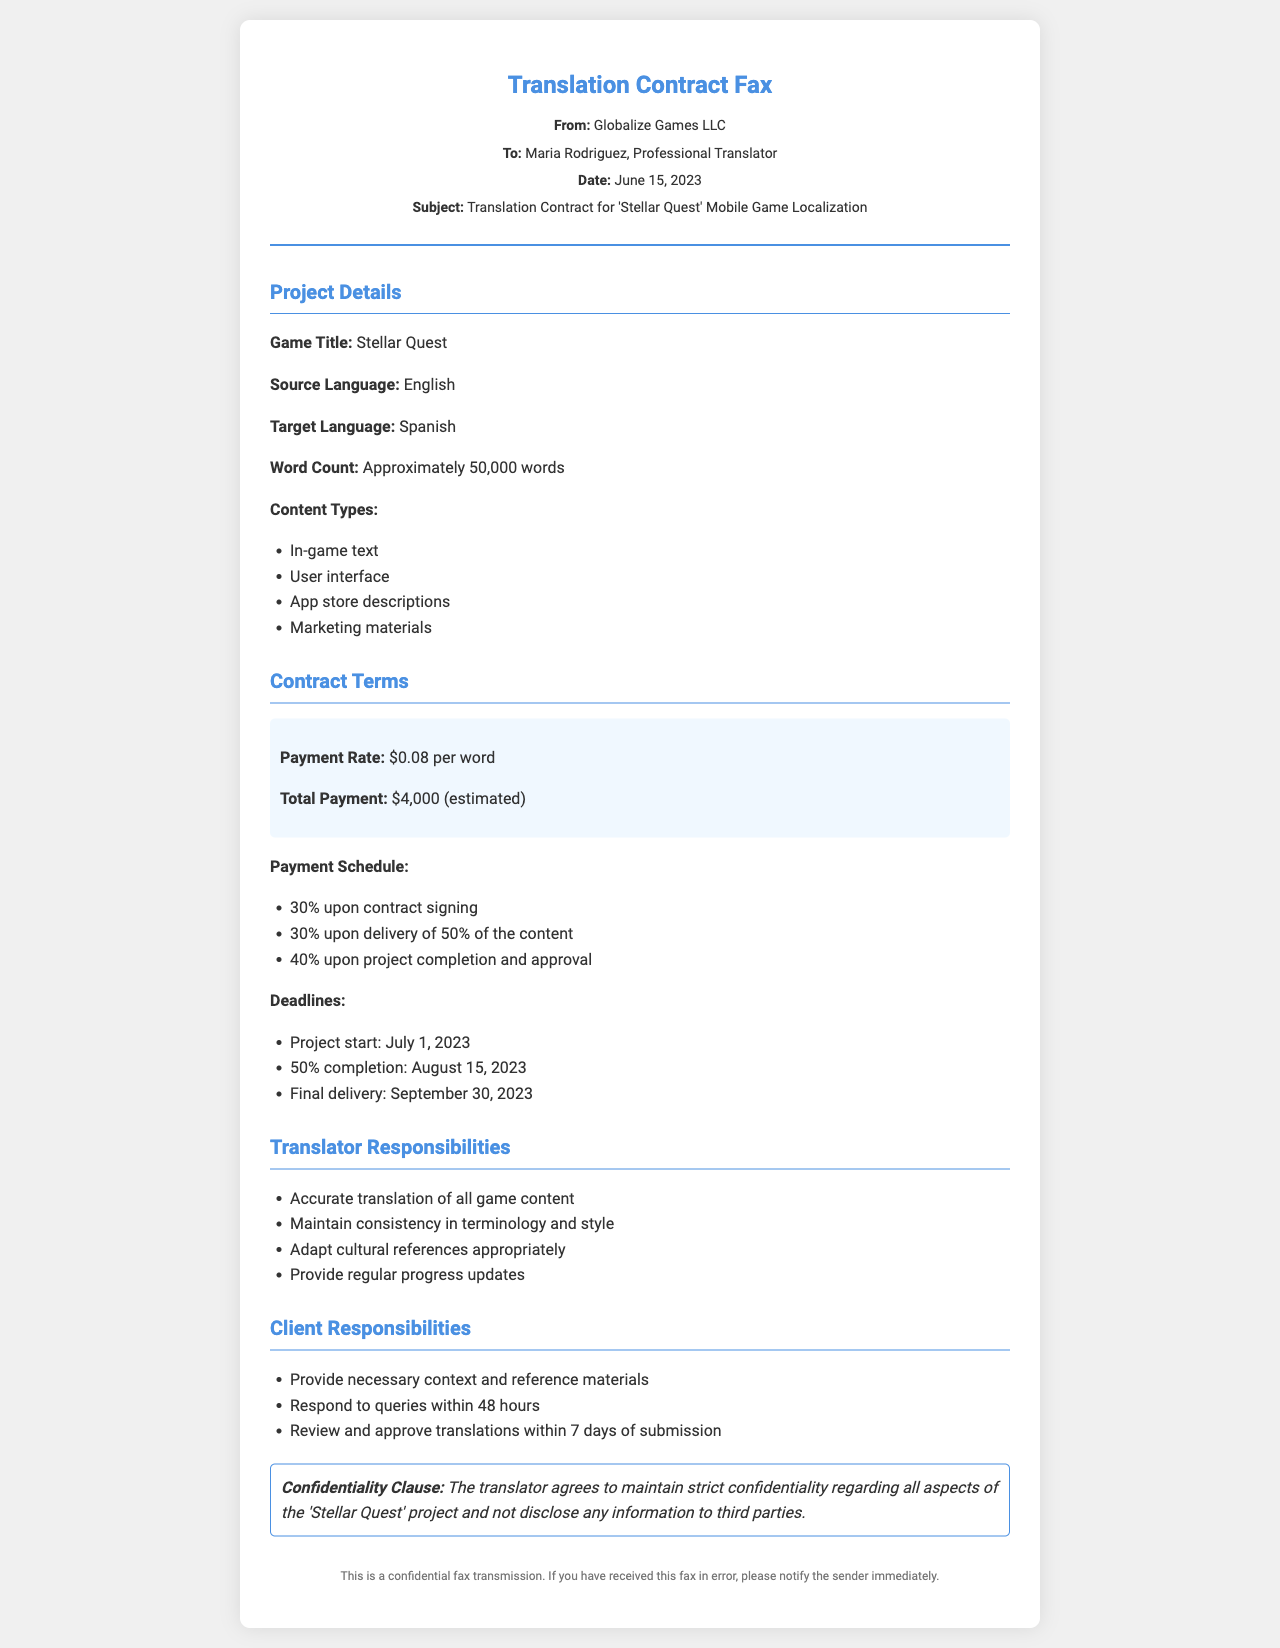what is the game title? The game title is stated in the project details section of the document.
Answer: Stellar Quest what is the source language? The source language is mentioned under project details.
Answer: English what is the target language? The target language is specified in the document.
Answer: Spanish what is the estimated total payment? The total payment is calculated based on the word count and payment rate.
Answer: $4,000 when is the final delivery date? The final delivery date is explicitly provided in the deadlines section.
Answer: September 30, 2023 how much is the payment upon contract signing? The payment upon contract signing is outlined in the payment schedule.
Answer: 30% what is the word count for the project? The word count is provided in the project details section.
Answer: Approximately 50,000 words what are the translator's responsibilities? The document lists multiple responsibilities for the translator.
Answer: Accurate translation of all game content what is the confidentiality clause about? The confidentiality clause describes the translator's obligation regarding project information.
Answer: Maintain strict confidentiality what is the deadline for 50% completion? The deadline for 50% completion is detailed in the deadlines section.
Answer: August 15, 2023 